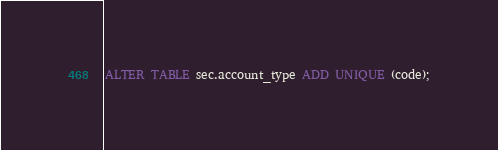Convert code to text. <code><loc_0><loc_0><loc_500><loc_500><_SQL_>ALTER TABLE sec.account_type ADD UNIQUE (code);</code> 